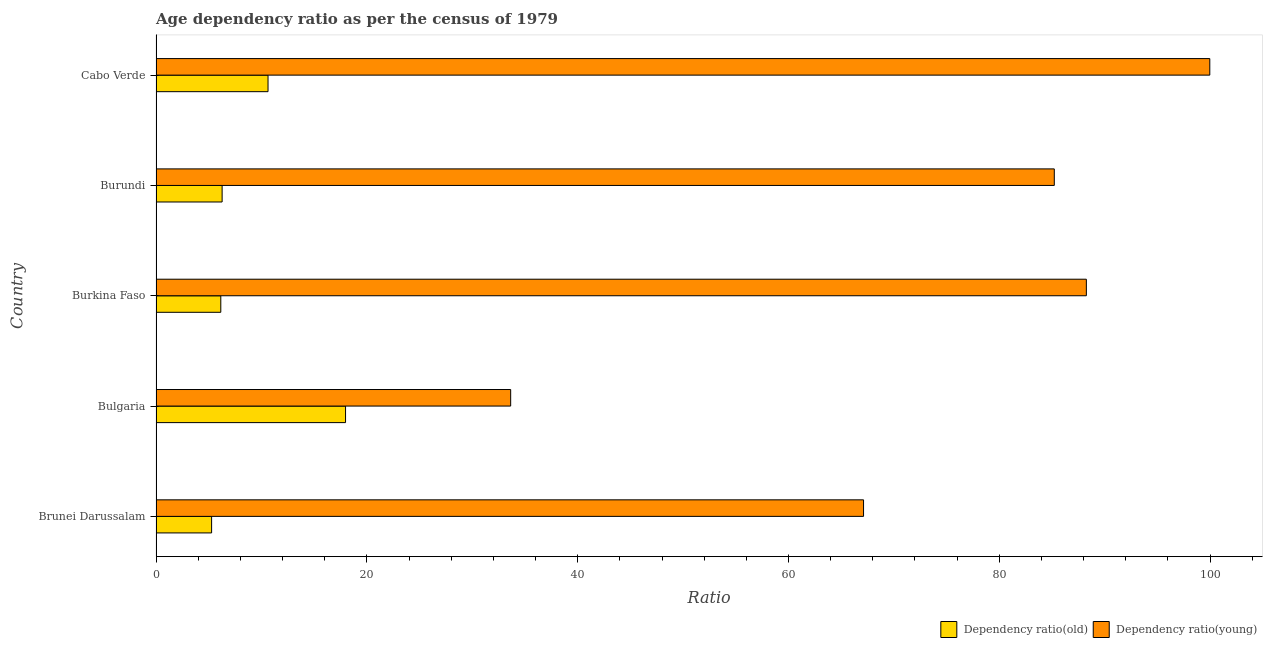How many different coloured bars are there?
Keep it short and to the point. 2. Are the number of bars per tick equal to the number of legend labels?
Your answer should be compact. Yes. Are the number of bars on each tick of the Y-axis equal?
Ensure brevity in your answer.  Yes. What is the label of the 4th group of bars from the top?
Provide a short and direct response. Bulgaria. What is the age dependency ratio(young) in Burkina Faso?
Give a very brief answer. 88.26. Across all countries, what is the maximum age dependency ratio(young)?
Your answer should be compact. 99.97. Across all countries, what is the minimum age dependency ratio(young)?
Your answer should be compact. 33.64. In which country was the age dependency ratio(young) maximum?
Your answer should be compact. Cabo Verde. In which country was the age dependency ratio(old) minimum?
Your answer should be very brief. Brunei Darussalam. What is the total age dependency ratio(old) in the graph?
Ensure brevity in your answer.  46.29. What is the difference between the age dependency ratio(young) in Bulgaria and that in Cabo Verde?
Ensure brevity in your answer.  -66.32. What is the difference between the age dependency ratio(old) in Burkina Faso and the age dependency ratio(young) in Cabo Verde?
Offer a terse response. -93.82. What is the average age dependency ratio(young) per country?
Provide a succinct answer. 74.84. What is the difference between the age dependency ratio(young) and age dependency ratio(old) in Bulgaria?
Keep it short and to the point. 15.66. What is the ratio of the age dependency ratio(old) in Bulgaria to that in Cabo Verde?
Your response must be concise. 1.69. Is the age dependency ratio(old) in Brunei Darussalam less than that in Cabo Verde?
Your answer should be very brief. Yes. What is the difference between the highest and the second highest age dependency ratio(old)?
Provide a short and direct response. 7.35. What is the difference between the highest and the lowest age dependency ratio(old)?
Provide a short and direct response. 12.71. In how many countries, is the age dependency ratio(young) greater than the average age dependency ratio(young) taken over all countries?
Offer a very short reply. 3. What does the 2nd bar from the top in Bulgaria represents?
Give a very brief answer. Dependency ratio(old). What does the 1st bar from the bottom in Bulgaria represents?
Keep it short and to the point. Dependency ratio(old). How many bars are there?
Provide a succinct answer. 10. How many countries are there in the graph?
Offer a very short reply. 5. Does the graph contain any zero values?
Provide a short and direct response. No. Does the graph contain grids?
Make the answer very short. No. How many legend labels are there?
Make the answer very short. 2. How are the legend labels stacked?
Your answer should be compact. Horizontal. What is the title of the graph?
Offer a terse response. Age dependency ratio as per the census of 1979. Does "Nitrous oxide emissions" appear as one of the legend labels in the graph?
Your answer should be very brief. No. What is the label or title of the X-axis?
Provide a succinct answer. Ratio. What is the label or title of the Y-axis?
Offer a terse response. Country. What is the Ratio in Dependency ratio(old) in Brunei Darussalam?
Make the answer very short. 5.27. What is the Ratio of Dependency ratio(young) in Brunei Darussalam?
Your answer should be compact. 67.12. What is the Ratio in Dependency ratio(old) in Bulgaria?
Keep it short and to the point. 17.98. What is the Ratio in Dependency ratio(young) in Bulgaria?
Ensure brevity in your answer.  33.64. What is the Ratio in Dependency ratio(old) in Burkina Faso?
Offer a terse response. 6.15. What is the Ratio of Dependency ratio(young) in Burkina Faso?
Your answer should be very brief. 88.26. What is the Ratio of Dependency ratio(old) in Burundi?
Provide a succinct answer. 6.27. What is the Ratio of Dependency ratio(young) in Burundi?
Your response must be concise. 85.21. What is the Ratio in Dependency ratio(old) in Cabo Verde?
Keep it short and to the point. 10.63. What is the Ratio of Dependency ratio(young) in Cabo Verde?
Make the answer very short. 99.97. Across all countries, what is the maximum Ratio in Dependency ratio(old)?
Give a very brief answer. 17.98. Across all countries, what is the maximum Ratio of Dependency ratio(young)?
Offer a very short reply. 99.97. Across all countries, what is the minimum Ratio in Dependency ratio(old)?
Make the answer very short. 5.27. Across all countries, what is the minimum Ratio of Dependency ratio(young)?
Provide a short and direct response. 33.64. What is the total Ratio of Dependency ratio(old) in the graph?
Keep it short and to the point. 46.29. What is the total Ratio of Dependency ratio(young) in the graph?
Keep it short and to the point. 374.2. What is the difference between the Ratio in Dependency ratio(old) in Brunei Darussalam and that in Bulgaria?
Offer a terse response. -12.71. What is the difference between the Ratio of Dependency ratio(young) in Brunei Darussalam and that in Bulgaria?
Offer a very short reply. 33.48. What is the difference between the Ratio in Dependency ratio(old) in Brunei Darussalam and that in Burkina Faso?
Make the answer very short. -0.87. What is the difference between the Ratio of Dependency ratio(young) in Brunei Darussalam and that in Burkina Faso?
Provide a succinct answer. -21.14. What is the difference between the Ratio in Dependency ratio(old) in Brunei Darussalam and that in Burundi?
Offer a terse response. -1. What is the difference between the Ratio of Dependency ratio(young) in Brunei Darussalam and that in Burundi?
Offer a very short reply. -18.09. What is the difference between the Ratio of Dependency ratio(old) in Brunei Darussalam and that in Cabo Verde?
Your answer should be very brief. -5.35. What is the difference between the Ratio of Dependency ratio(young) in Brunei Darussalam and that in Cabo Verde?
Offer a very short reply. -32.85. What is the difference between the Ratio in Dependency ratio(old) in Bulgaria and that in Burkina Faso?
Provide a succinct answer. 11.83. What is the difference between the Ratio of Dependency ratio(young) in Bulgaria and that in Burkina Faso?
Provide a short and direct response. -54.61. What is the difference between the Ratio in Dependency ratio(old) in Bulgaria and that in Burundi?
Provide a short and direct response. 11.71. What is the difference between the Ratio of Dependency ratio(young) in Bulgaria and that in Burundi?
Your answer should be very brief. -51.57. What is the difference between the Ratio in Dependency ratio(old) in Bulgaria and that in Cabo Verde?
Your answer should be compact. 7.35. What is the difference between the Ratio in Dependency ratio(young) in Bulgaria and that in Cabo Verde?
Your response must be concise. -66.32. What is the difference between the Ratio of Dependency ratio(old) in Burkina Faso and that in Burundi?
Provide a succinct answer. -0.13. What is the difference between the Ratio in Dependency ratio(young) in Burkina Faso and that in Burundi?
Provide a succinct answer. 3.04. What is the difference between the Ratio of Dependency ratio(old) in Burkina Faso and that in Cabo Verde?
Your response must be concise. -4.48. What is the difference between the Ratio in Dependency ratio(young) in Burkina Faso and that in Cabo Verde?
Offer a terse response. -11.71. What is the difference between the Ratio of Dependency ratio(old) in Burundi and that in Cabo Verde?
Your response must be concise. -4.36. What is the difference between the Ratio of Dependency ratio(young) in Burundi and that in Cabo Verde?
Provide a succinct answer. -14.75. What is the difference between the Ratio in Dependency ratio(old) in Brunei Darussalam and the Ratio in Dependency ratio(young) in Bulgaria?
Your answer should be compact. -28.37. What is the difference between the Ratio of Dependency ratio(old) in Brunei Darussalam and the Ratio of Dependency ratio(young) in Burkina Faso?
Provide a succinct answer. -82.98. What is the difference between the Ratio of Dependency ratio(old) in Brunei Darussalam and the Ratio of Dependency ratio(young) in Burundi?
Your answer should be compact. -79.94. What is the difference between the Ratio of Dependency ratio(old) in Brunei Darussalam and the Ratio of Dependency ratio(young) in Cabo Verde?
Provide a short and direct response. -94.7. What is the difference between the Ratio of Dependency ratio(old) in Bulgaria and the Ratio of Dependency ratio(young) in Burkina Faso?
Offer a very short reply. -70.28. What is the difference between the Ratio in Dependency ratio(old) in Bulgaria and the Ratio in Dependency ratio(young) in Burundi?
Keep it short and to the point. -67.24. What is the difference between the Ratio of Dependency ratio(old) in Bulgaria and the Ratio of Dependency ratio(young) in Cabo Verde?
Provide a succinct answer. -81.99. What is the difference between the Ratio in Dependency ratio(old) in Burkina Faso and the Ratio in Dependency ratio(young) in Burundi?
Offer a very short reply. -79.07. What is the difference between the Ratio of Dependency ratio(old) in Burkina Faso and the Ratio of Dependency ratio(young) in Cabo Verde?
Your answer should be very brief. -93.82. What is the difference between the Ratio in Dependency ratio(old) in Burundi and the Ratio in Dependency ratio(young) in Cabo Verde?
Give a very brief answer. -93.7. What is the average Ratio in Dependency ratio(old) per country?
Provide a succinct answer. 9.26. What is the average Ratio of Dependency ratio(young) per country?
Make the answer very short. 74.84. What is the difference between the Ratio in Dependency ratio(old) and Ratio in Dependency ratio(young) in Brunei Darussalam?
Offer a very short reply. -61.85. What is the difference between the Ratio in Dependency ratio(old) and Ratio in Dependency ratio(young) in Bulgaria?
Keep it short and to the point. -15.66. What is the difference between the Ratio of Dependency ratio(old) and Ratio of Dependency ratio(young) in Burkina Faso?
Give a very brief answer. -82.11. What is the difference between the Ratio in Dependency ratio(old) and Ratio in Dependency ratio(young) in Burundi?
Ensure brevity in your answer.  -78.94. What is the difference between the Ratio in Dependency ratio(old) and Ratio in Dependency ratio(young) in Cabo Verde?
Your response must be concise. -89.34. What is the ratio of the Ratio in Dependency ratio(old) in Brunei Darussalam to that in Bulgaria?
Offer a very short reply. 0.29. What is the ratio of the Ratio in Dependency ratio(young) in Brunei Darussalam to that in Bulgaria?
Provide a short and direct response. 2. What is the ratio of the Ratio of Dependency ratio(old) in Brunei Darussalam to that in Burkina Faso?
Your response must be concise. 0.86. What is the ratio of the Ratio of Dependency ratio(young) in Brunei Darussalam to that in Burkina Faso?
Give a very brief answer. 0.76. What is the ratio of the Ratio of Dependency ratio(old) in Brunei Darussalam to that in Burundi?
Your response must be concise. 0.84. What is the ratio of the Ratio of Dependency ratio(young) in Brunei Darussalam to that in Burundi?
Your answer should be compact. 0.79. What is the ratio of the Ratio in Dependency ratio(old) in Brunei Darussalam to that in Cabo Verde?
Keep it short and to the point. 0.5. What is the ratio of the Ratio in Dependency ratio(young) in Brunei Darussalam to that in Cabo Verde?
Make the answer very short. 0.67. What is the ratio of the Ratio of Dependency ratio(old) in Bulgaria to that in Burkina Faso?
Offer a very short reply. 2.93. What is the ratio of the Ratio in Dependency ratio(young) in Bulgaria to that in Burkina Faso?
Ensure brevity in your answer.  0.38. What is the ratio of the Ratio of Dependency ratio(old) in Bulgaria to that in Burundi?
Ensure brevity in your answer.  2.87. What is the ratio of the Ratio in Dependency ratio(young) in Bulgaria to that in Burundi?
Give a very brief answer. 0.39. What is the ratio of the Ratio in Dependency ratio(old) in Bulgaria to that in Cabo Verde?
Provide a succinct answer. 1.69. What is the ratio of the Ratio of Dependency ratio(young) in Bulgaria to that in Cabo Verde?
Provide a succinct answer. 0.34. What is the ratio of the Ratio of Dependency ratio(young) in Burkina Faso to that in Burundi?
Ensure brevity in your answer.  1.04. What is the ratio of the Ratio of Dependency ratio(old) in Burkina Faso to that in Cabo Verde?
Give a very brief answer. 0.58. What is the ratio of the Ratio in Dependency ratio(young) in Burkina Faso to that in Cabo Verde?
Your answer should be very brief. 0.88. What is the ratio of the Ratio of Dependency ratio(old) in Burundi to that in Cabo Verde?
Give a very brief answer. 0.59. What is the ratio of the Ratio in Dependency ratio(young) in Burundi to that in Cabo Verde?
Your answer should be compact. 0.85. What is the difference between the highest and the second highest Ratio in Dependency ratio(old)?
Ensure brevity in your answer.  7.35. What is the difference between the highest and the second highest Ratio of Dependency ratio(young)?
Your answer should be very brief. 11.71. What is the difference between the highest and the lowest Ratio in Dependency ratio(old)?
Your response must be concise. 12.71. What is the difference between the highest and the lowest Ratio in Dependency ratio(young)?
Provide a short and direct response. 66.32. 